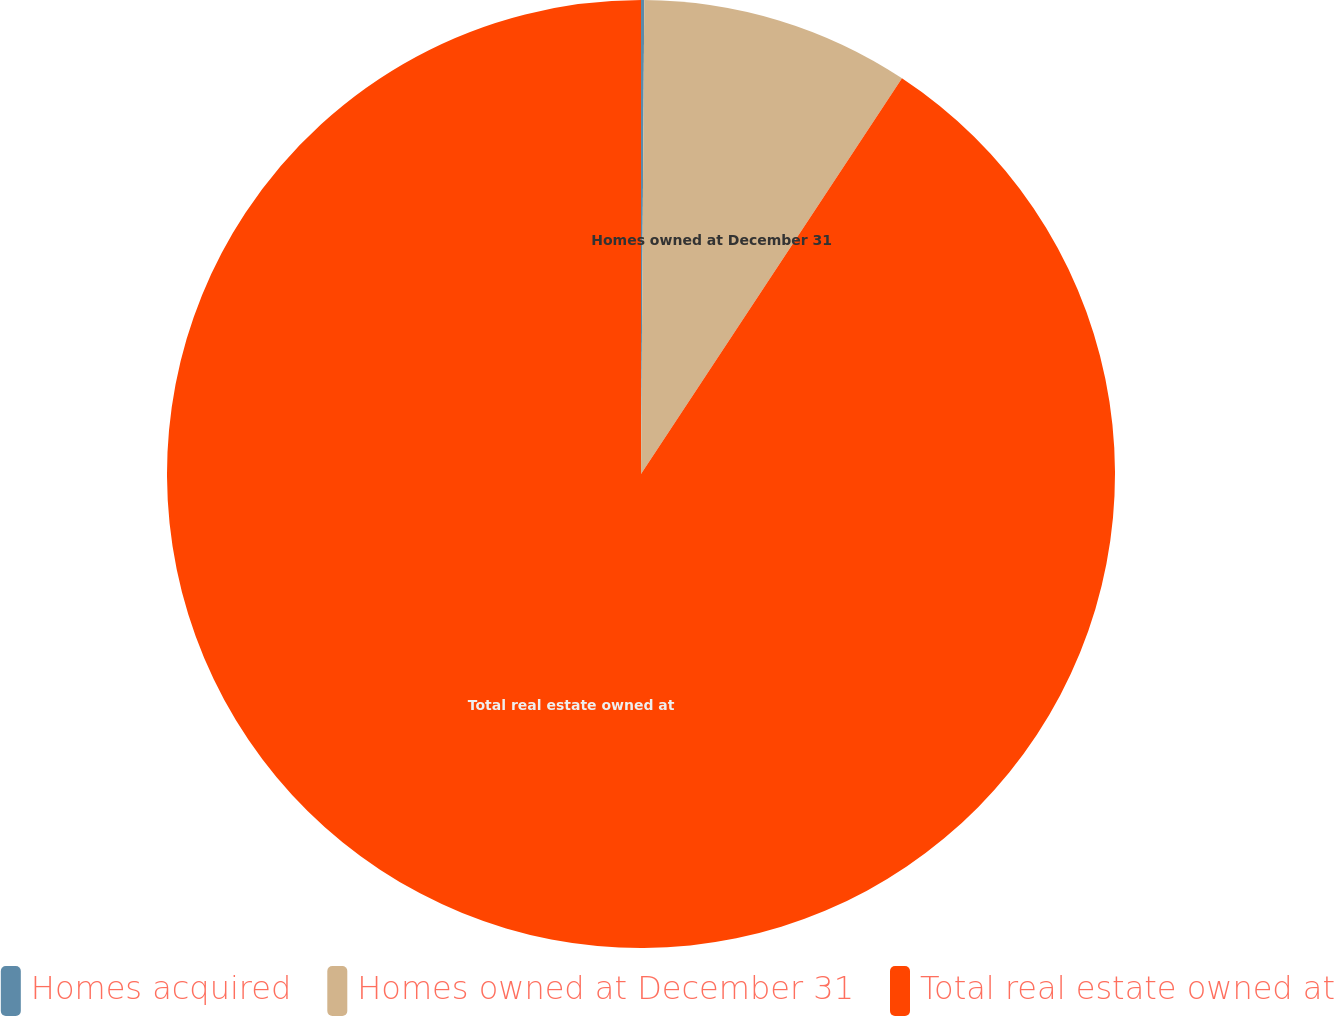Convert chart. <chart><loc_0><loc_0><loc_500><loc_500><pie_chart><fcel>Homes acquired<fcel>Homes owned at December 31<fcel>Total real estate owned at<nl><fcel>0.11%<fcel>9.17%<fcel>90.72%<nl></chart> 